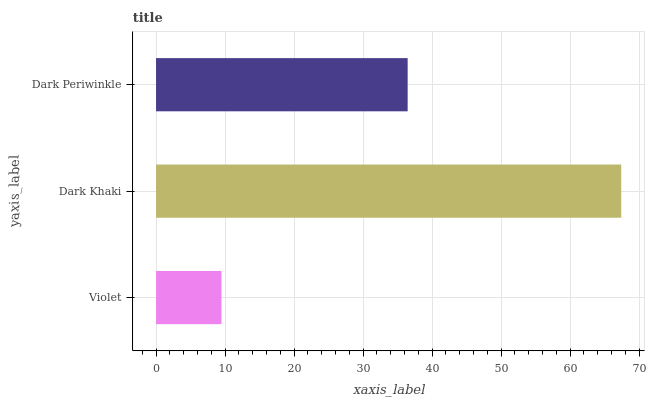Is Violet the minimum?
Answer yes or no. Yes. Is Dark Khaki the maximum?
Answer yes or no. Yes. Is Dark Periwinkle the minimum?
Answer yes or no. No. Is Dark Periwinkle the maximum?
Answer yes or no. No. Is Dark Khaki greater than Dark Periwinkle?
Answer yes or no. Yes. Is Dark Periwinkle less than Dark Khaki?
Answer yes or no. Yes. Is Dark Periwinkle greater than Dark Khaki?
Answer yes or no. No. Is Dark Khaki less than Dark Periwinkle?
Answer yes or no. No. Is Dark Periwinkle the high median?
Answer yes or no. Yes. Is Dark Periwinkle the low median?
Answer yes or no. Yes. Is Violet the high median?
Answer yes or no. No. Is Violet the low median?
Answer yes or no. No. 